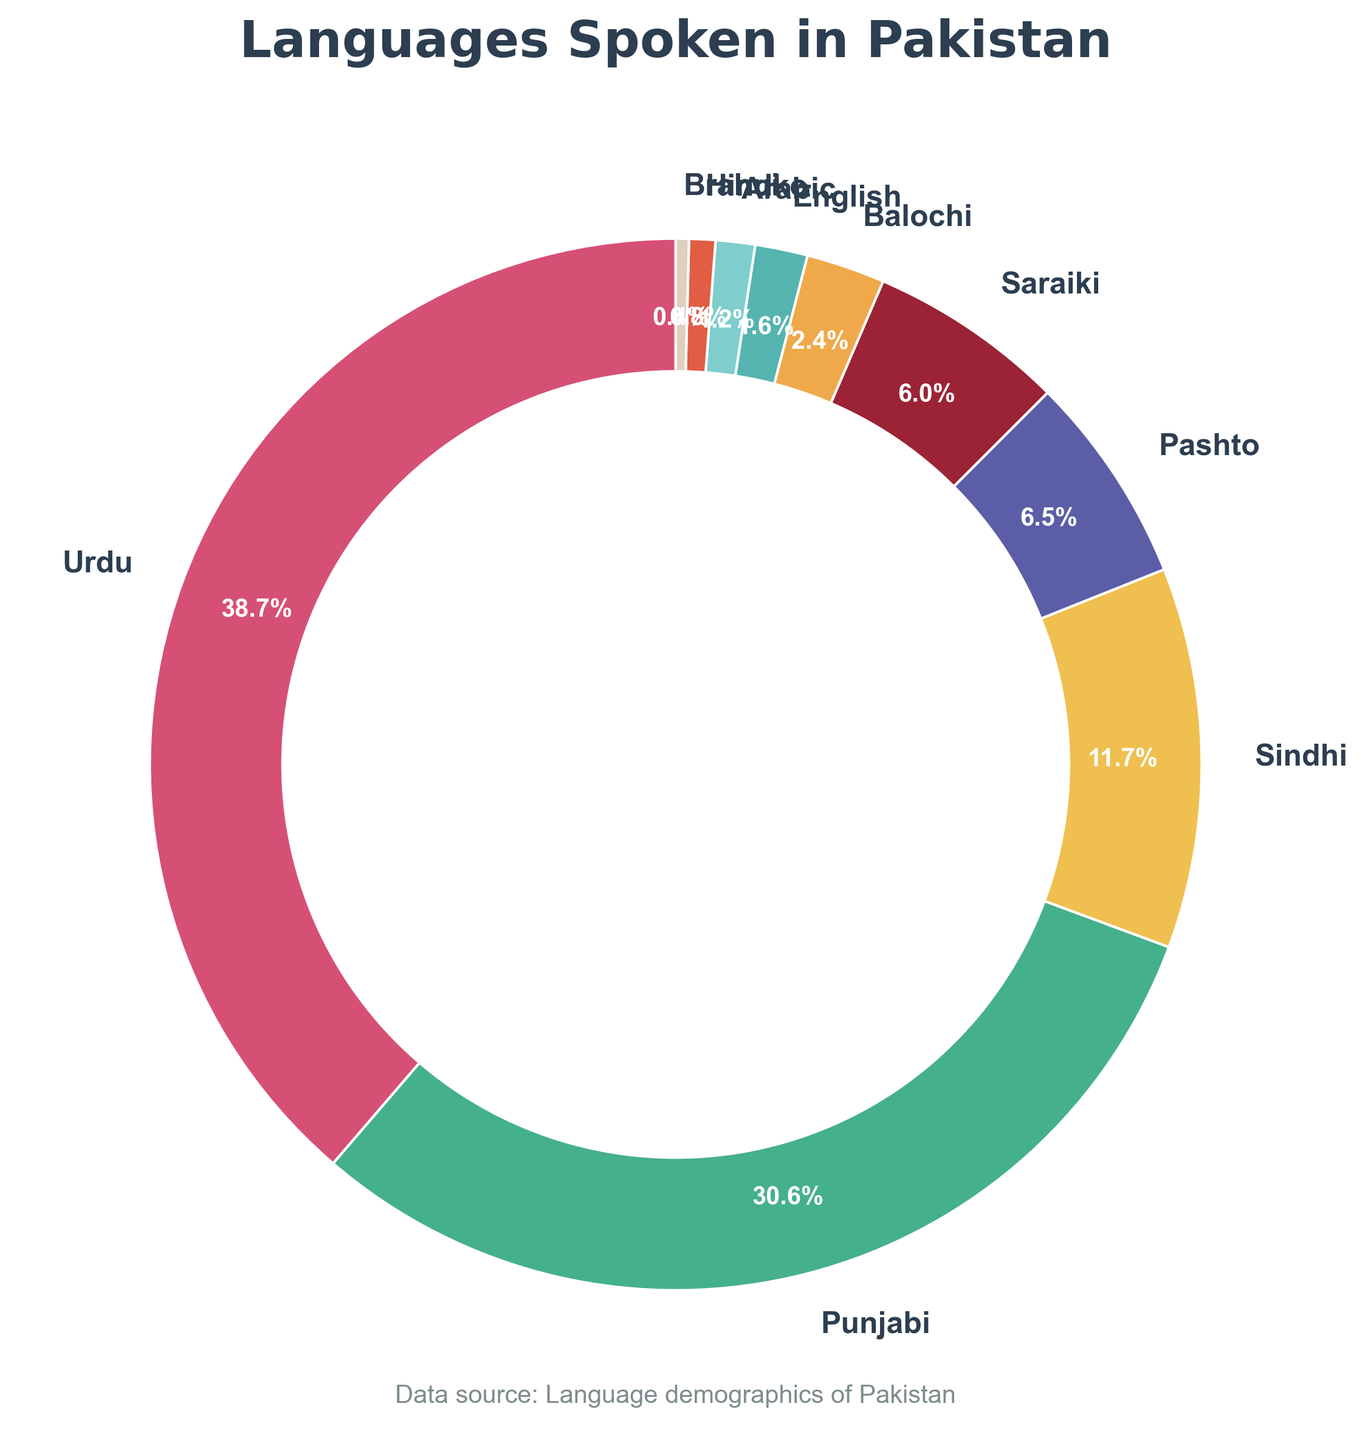What is the most spoken language in Pakistan according to the pie chart? The pie chart shows different languages and their corresponding percentages. By looking at the wedges, the largest wedge represents Urdu at 48%.
Answer: Urdu What is the combined percentage of Punjabi and Sindhi speakers in Pakistan? First, identify the percentages for Punjabi and Sindhi: Punjabi is 38% and Sindhi is 14.5%. Then, add these percentages together: 38% + 14.5% = 52.5%.
Answer: 52.5% Which language has the smallest percentage of speakers, and what is that percentage? The pie chart shows multiple wedges with their percentages. The smallest wedge represents Brahui with 0.5%.
Answer: Brahui, 0.5% How does the percentage of Pashto speakers compare to the percentage of Saraiki speakers? The pie chart shows that Pashto speakers make up 8% while Saraiki speakers constitute 7.5%. By comparing these figures, we can see that 8% is slightly higher than 7.5%.
Answer: Pashto speakers (8%) are slightly more than Saraiki speakers (7.5%) What languages have a combined total of at least 21% but less than 30% of the speakers? Individual percentages for each language should be identified and summed together to find a combination that fits within the specified range. Pashto (8%), Saraiki (7.5%), Balochi (3%), and English (2%) sum to a total 20.5%, while adding Arabic (1.5%) produces 22%.
Answer: Pashto, Saraiki, and Balochi (8% + 7.5% + 3% = 18.5%) Combining which three languages results in the second highest total percentage after Urdu? First, identify the percentages of the next largest wedges after Urdu (48%). Combining the next three largest percentages, Punjabi (38%), Sindhi (14.5%), and Pashto (8%) gives a total of 60.5%.
Answer: Punjabi, Sindhi, and Pashto (38% + 14.5% + 8% = 60.5%) What percentage of the population speaks languages other than Urdu and Punjabi? Subtract the combined percentage of Urdu and Punjabi from the total (100%). Urdu and Punjabi together are 48% + 38% = 86%. Remaining percentage = 100% - 86% = 14%.
Answer: 14% If a survey included 1000 people, how many would be expected to speak Hindko? The percentage of Hindko speakers is given as 1%. Therefore, 1% of 1000 people can be calculated as (1/100)*1000 = 10.
Answer: 10 How do the combined percentages of English and Arabic speakers compare to the percentage of Sindhi speakers? Compare the sum of English (2%) and Arabic (1.5%) to the percentage of Sindhi (14.5%). The sum is 2% + 1.5% = 3.5%, which is less than 14.5%.
Answer: The combined percentage of English and Arabic is less than Sindhi (3.5% < 14.5%) Which languages use warm colors in the pie chart? (e.g., shades of red, orange, yellow) Identify wedges in warm colors: Urdu (red), Sindhi (yellow), Saraiki (light orange), Arabic (orange), and Balochi (deep red).
Answer: Urdu, Sindhi, Saraiki, Arabic, Balochi 